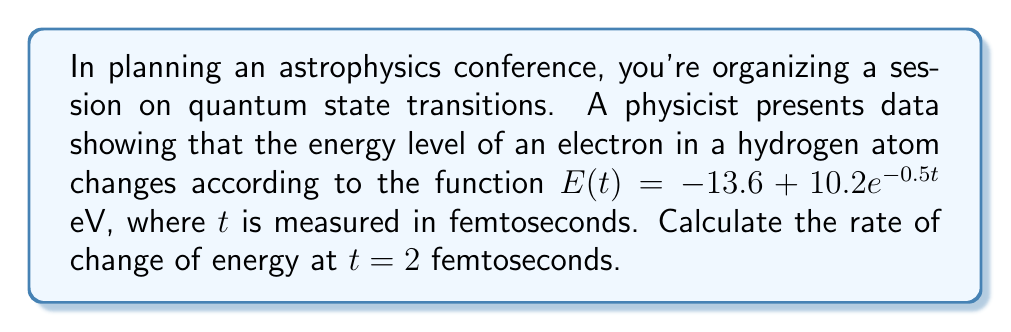Solve this math problem. To find the rate of change of energy, we need to calculate the derivative of the energy function with respect to time and then evaluate it at $t = 2$ fs.

1) The given energy function is:
   $E(t) = -13.6 + 10.2e^{-0.5t}$ eV

2) To find the rate of change, we need to differentiate $E(t)$ with respect to $t$:
   $$\frac{dE}{dt} = \frac{d}{dt}(-13.6 + 10.2e^{-0.5t})$$

3) The derivative of a constant is 0, and we can use the chain rule for the exponential term:
   $$\frac{dE}{dt} = 0 + 10.2 \cdot (-0.5) \cdot e^{-0.5t}$$

4) Simplify:
   $$\frac{dE}{dt} = -5.1e^{-0.5t}$$ eV/fs

5) Now, we evaluate this at $t = 2$ fs:
   $$\frac{dE}{dt}\bigg|_{t=2} = -5.1e^{-0.5(2)}$$

6) Calculate:
   $$\frac{dE}{dt}\bigg|_{t=2} = -5.1e^{-1} \approx -1.876$$ eV/fs

Therefore, at $t = 2$ fs, the rate of change of energy is approximately -1.876 eV/fs.
Answer: $-1.876$ eV/fs 